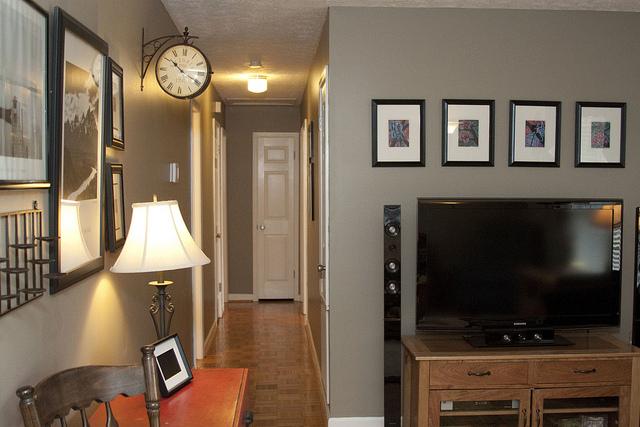What color is the lampshade beside the window?
Answer briefly. White. Is the TV on?
Give a very brief answer. No. Where was the photo taken?
Short answer required. Living room. What color is the walls?
Quick response, please. Gray. How much longer until it will be 4:20?
Write a very short answer. 6 hours. 